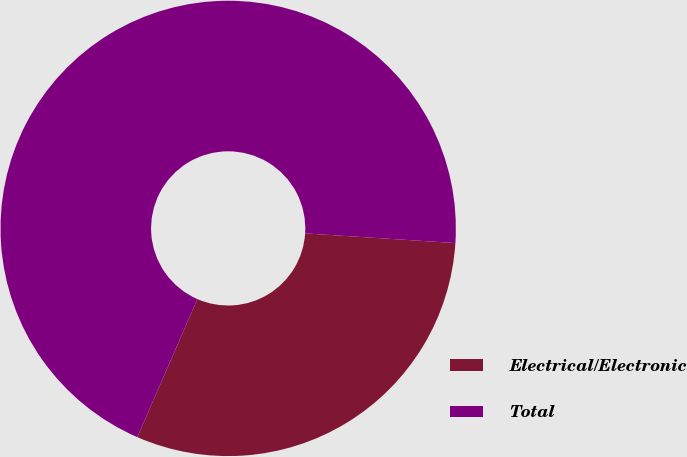<chart> <loc_0><loc_0><loc_500><loc_500><pie_chart><fcel>Electrical/Electronic<fcel>Total<nl><fcel>30.51%<fcel>69.49%<nl></chart> 